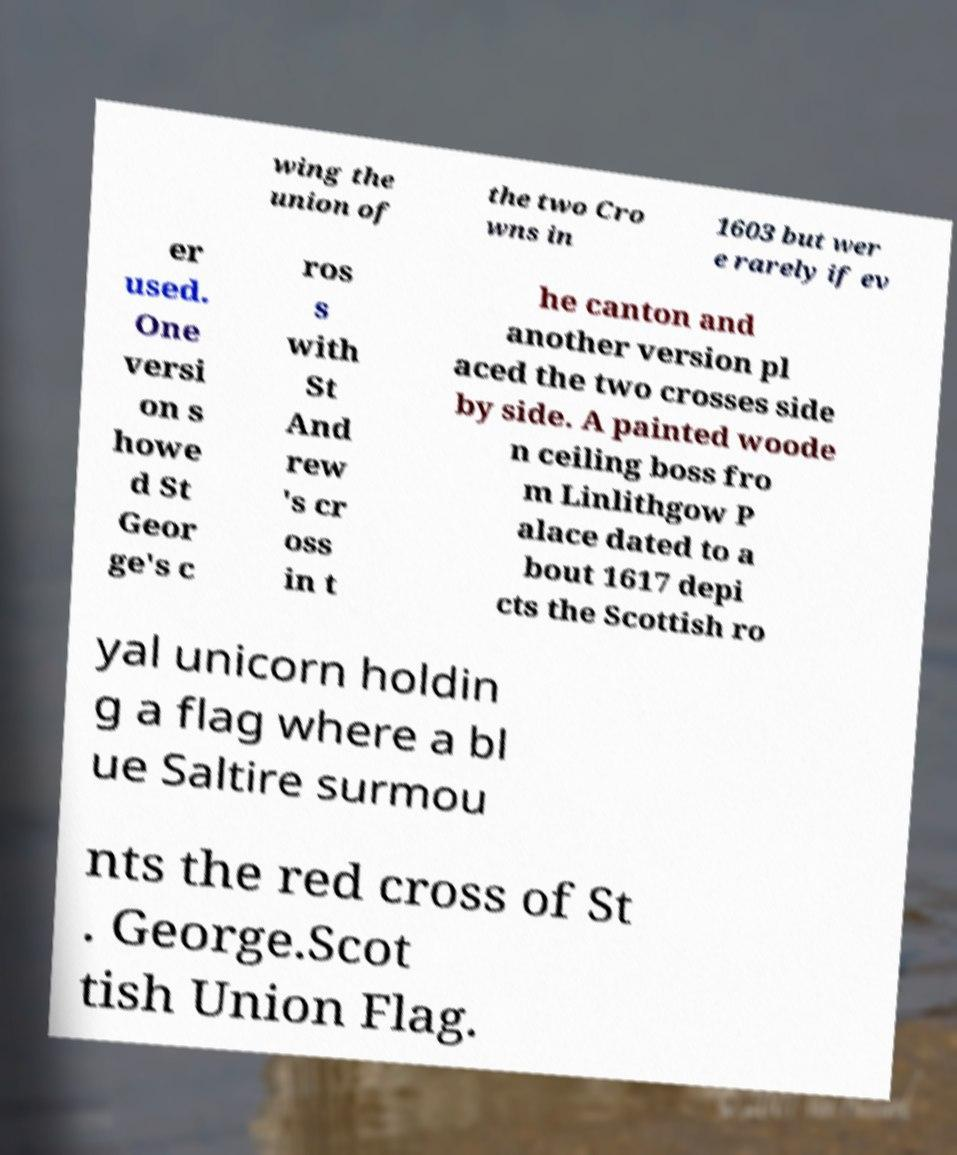I need the written content from this picture converted into text. Can you do that? wing the union of the two Cro wns in 1603 but wer e rarely if ev er used. One versi on s howe d St Geor ge's c ros s with St And rew 's cr oss in t he canton and another version pl aced the two crosses side by side. A painted woode n ceiling boss fro m Linlithgow P alace dated to a bout 1617 depi cts the Scottish ro yal unicorn holdin g a flag where a bl ue Saltire surmou nts the red cross of St . George.Scot tish Union Flag. 